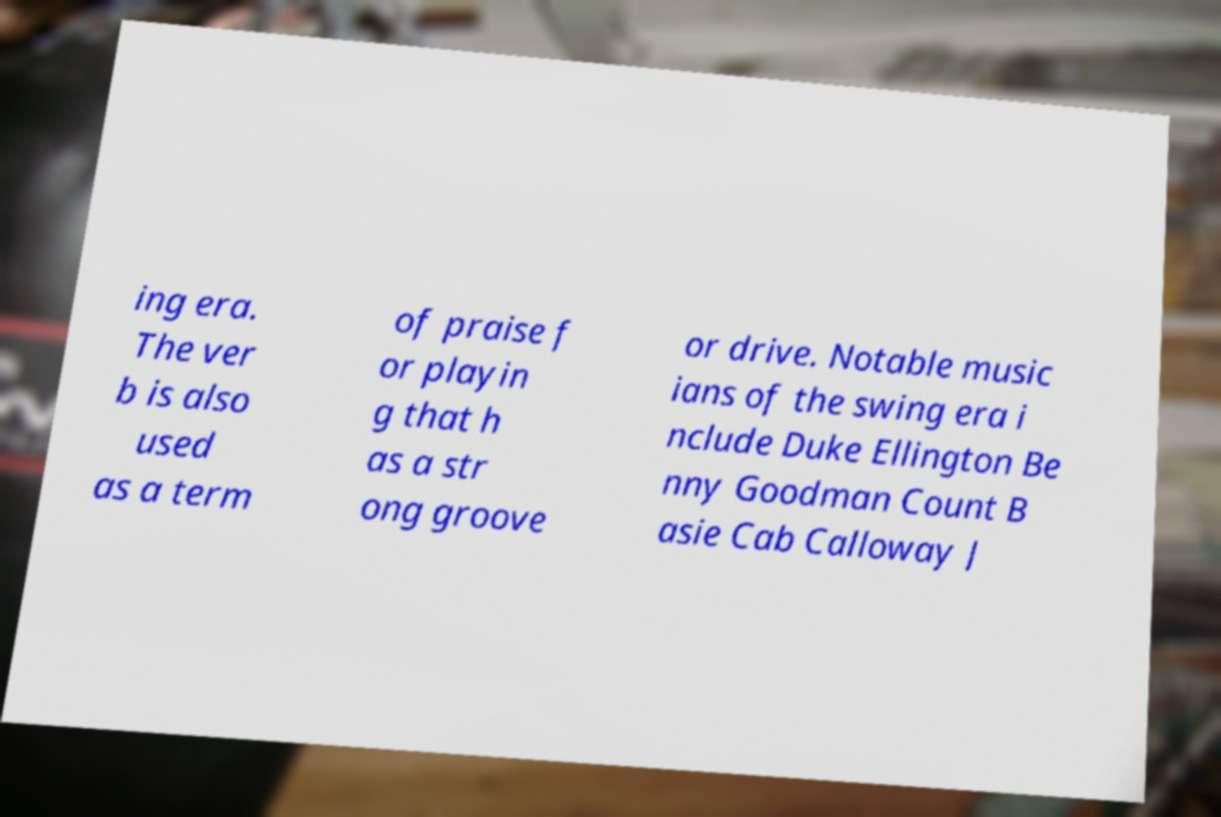Could you extract and type out the text from this image? ing era. The ver b is also used as a term of praise f or playin g that h as a str ong groove or drive. Notable music ians of the swing era i nclude Duke Ellington Be nny Goodman Count B asie Cab Calloway J 